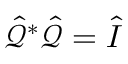Convert formula to latex. <formula><loc_0><loc_0><loc_500><loc_500>\hat { \mathcal { Q } } ^ { * } \hat { \mathcal { Q } } = \hat { I }</formula> 